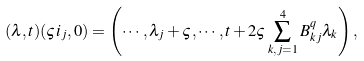<formula> <loc_0><loc_0><loc_500><loc_500>( \lambda , t ) ( \varsigma i _ { j } , 0 ) = \left ( \cdots , \lambda _ { j } + \varsigma , \cdots , t + 2 \varsigma \sum _ { k , j = 1 } ^ { 4 } B ^ { q } _ { k j } \lambda _ { k } \right ) ,</formula> 